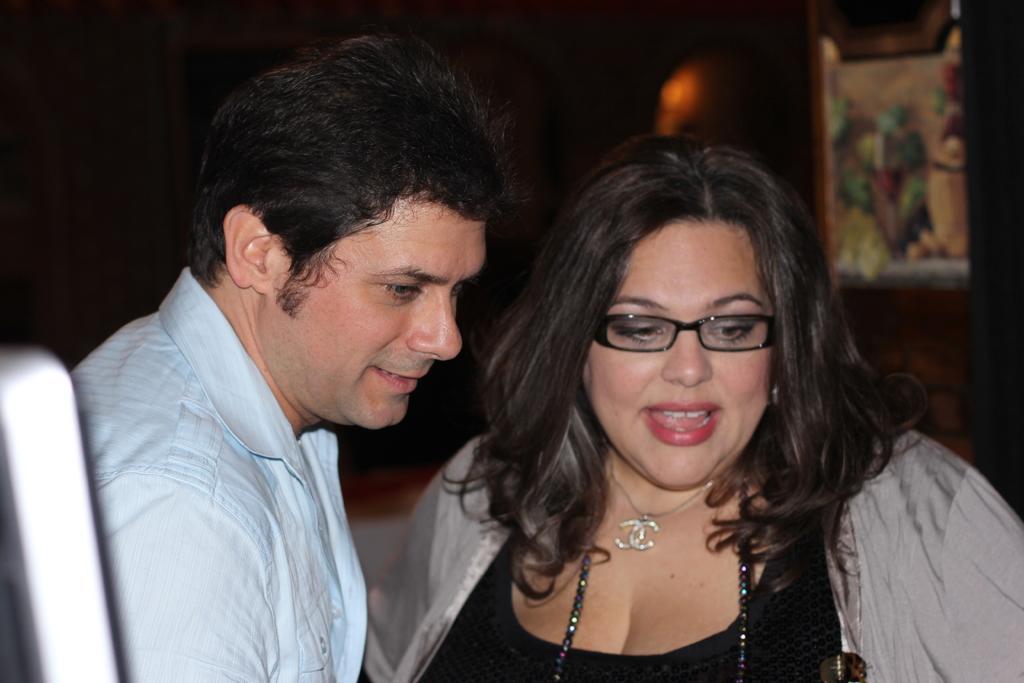Can you describe this image briefly? On the right side, there is a woman in black color t-shirt, wearing a spectacle and speaking. Beside her, there is a person in blue color shirt, smiling. In the background, there is a light and there is a photo frame. And the background is dark in color. 